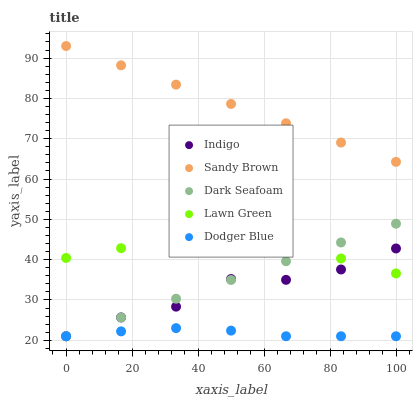Does Dodger Blue have the minimum area under the curve?
Answer yes or no. Yes. Does Sandy Brown have the maximum area under the curve?
Answer yes or no. Yes. Does Dark Seafoam have the minimum area under the curve?
Answer yes or no. No. Does Dark Seafoam have the maximum area under the curve?
Answer yes or no. No. Is Sandy Brown the smoothest?
Answer yes or no. Yes. Is Indigo the roughest?
Answer yes or no. Yes. Is Indigo the smoothest?
Answer yes or no. No. Is Dark Seafoam the roughest?
Answer yes or no. No. Does Dark Seafoam have the lowest value?
Answer yes or no. Yes. Does Lawn Green have the lowest value?
Answer yes or no. No. Does Sandy Brown have the highest value?
Answer yes or no. Yes. Does Dark Seafoam have the highest value?
Answer yes or no. No. Is Indigo less than Sandy Brown?
Answer yes or no. Yes. Is Sandy Brown greater than Indigo?
Answer yes or no. Yes. Does Dark Seafoam intersect Dodger Blue?
Answer yes or no. Yes. Is Dark Seafoam less than Dodger Blue?
Answer yes or no. No. Is Dark Seafoam greater than Dodger Blue?
Answer yes or no. No. Does Indigo intersect Sandy Brown?
Answer yes or no. No. 